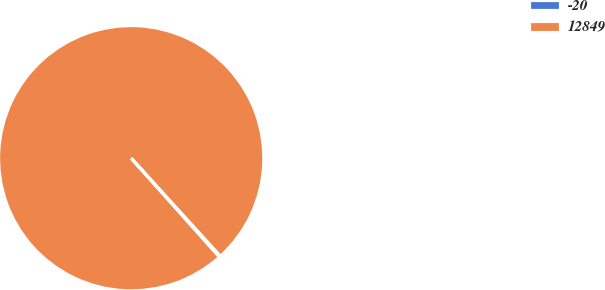Convert chart. <chart><loc_0><loc_0><loc_500><loc_500><pie_chart><fcel>-20<fcel>12849<nl><fcel>0.16%<fcel>99.84%<nl></chart> 